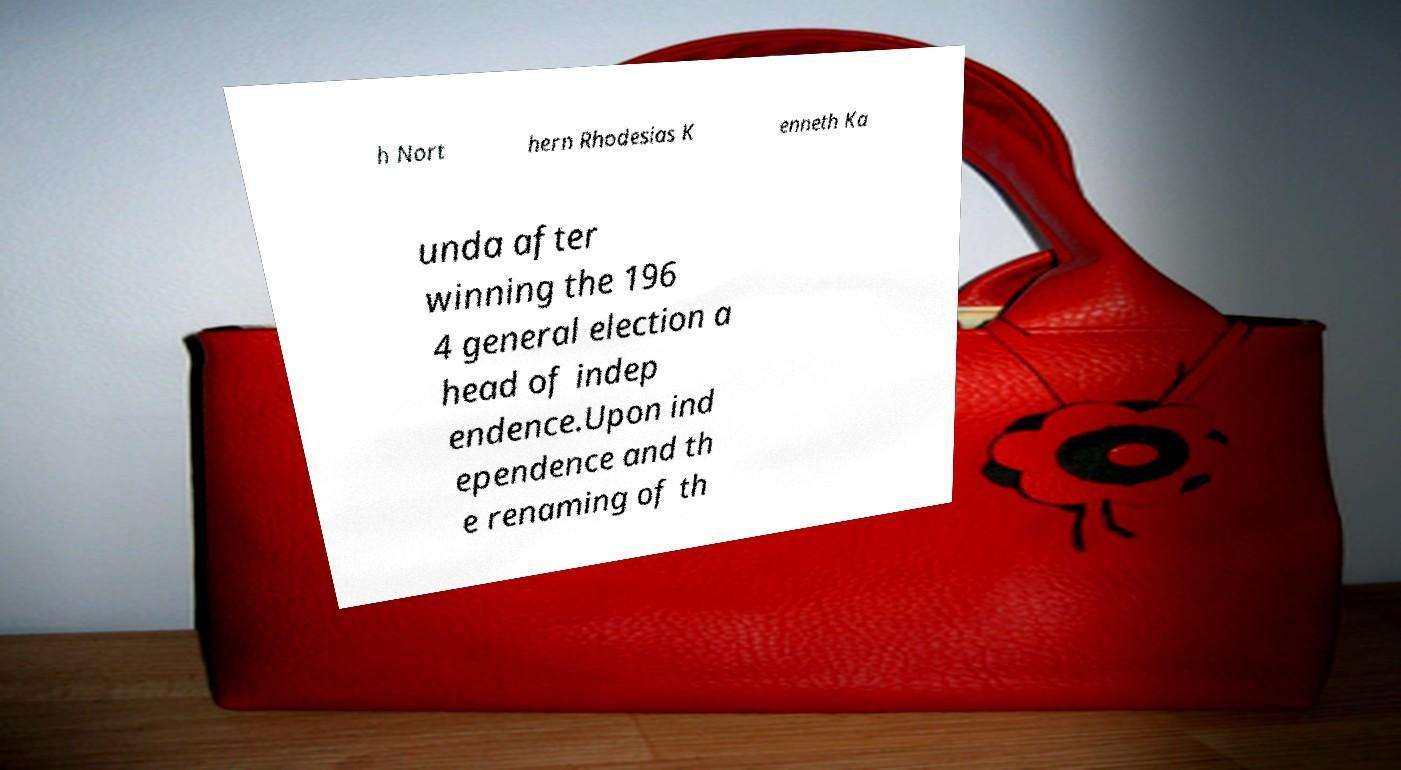Can you accurately transcribe the text from the provided image for me? h Nort hern Rhodesias K enneth Ka unda after winning the 196 4 general election a head of indep endence.Upon ind ependence and th e renaming of th 